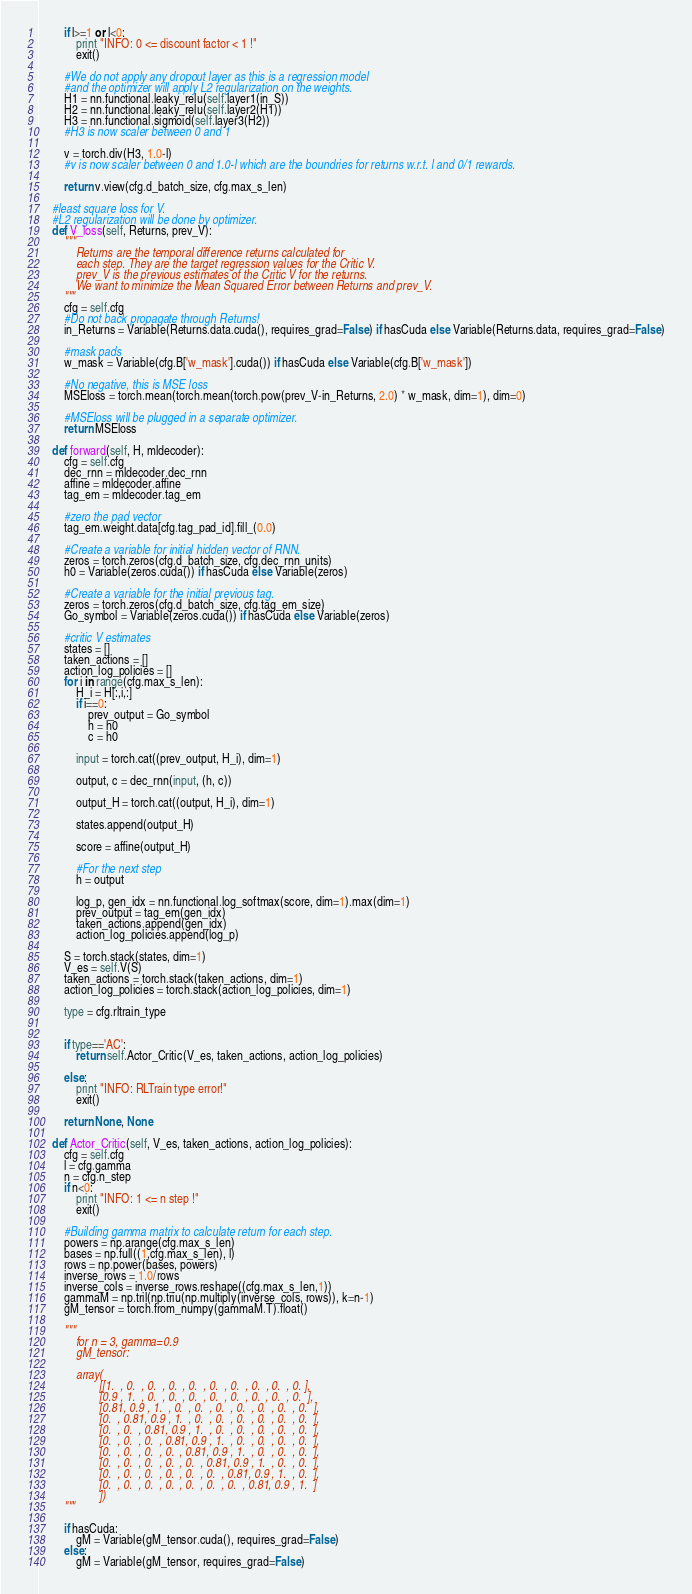<code> <loc_0><loc_0><loc_500><loc_500><_Python_>        if l>=1 or l<0:
            print "INFO: 0 <= discount factor < 1 !"
            exit()

        #We do not apply any dropout layer as this is a regression model
        #and the optimizer will apply L2 regularization on the weights.
        H1 = nn.functional.leaky_relu(self.layer1(in_S))
        H2 = nn.functional.leaky_relu(self.layer2(H1))
        H3 = nn.functional.sigmoid(self.layer3(H2))
        #H3 is now scaler between 0 and 1

        v = torch.div(H3, 1.0-l)
        #v is now scaler between 0 and 1.0-l which are the boundries for returns w.r.t. l and 0/1 rewards.

        return v.view(cfg.d_batch_size, cfg.max_s_len)

    #least square loss for V.
    #L2 regularization will be done by optimizer.
    def V_loss(self, Returns, prev_V):
        """
            Returns are the temporal difference returns calculated for
            each step. They are the target regression values for the Critic V.
            prev_V is the previous estimates of the Critic V for the returns.
            We want to minimize the Mean Squared Error between Returns and prev_V.
        """
        cfg = self.cfg
        #Do not back propagate through Returns!
        in_Returns = Variable(Returns.data.cuda(), requires_grad=False) if hasCuda else Variable(Returns.data, requires_grad=False)

        #mask pads
        w_mask = Variable(cfg.B['w_mask'].cuda()) if hasCuda else Variable(cfg.B['w_mask'])

        #No negative, this is MSE loss
        MSEloss = torch.mean(torch.mean(torch.pow(prev_V-in_Returns, 2.0) * w_mask, dim=1), dim=0)

        #MSEloss will be plugged in a separate optimizer.
        return MSEloss

    def forward(self, H, mldecoder):
        cfg = self.cfg
        dec_rnn = mldecoder.dec_rnn
        affine = mldecoder.affine
        tag_em = mldecoder.tag_em

        #zero the pad vector
        tag_em.weight.data[cfg.tag_pad_id].fill_(0.0)

        #Create a variable for initial hidden vector of RNN.
        zeros = torch.zeros(cfg.d_batch_size, cfg.dec_rnn_units)
        h0 = Variable(zeros.cuda()) if hasCuda else Variable(zeros)

        #Create a variable for the initial previous tag.
        zeros = torch.zeros(cfg.d_batch_size, cfg.tag_em_size)
        Go_symbol = Variable(zeros.cuda()) if hasCuda else Variable(zeros)

        #critic V estimates
        states = []
        taken_actions = []
        action_log_policies = []
        for i in range(cfg.max_s_len):
            H_i = H[:,i,:]
            if i==0:
                prev_output = Go_symbol
                h = h0
                c = h0

            input = torch.cat((prev_output, H_i), dim=1)

            output, c = dec_rnn(input, (h, c))

            output_H = torch.cat((output, H_i), dim=1)

            states.append(output_H)

            score = affine(output_H)

            #For the next step
            h = output

            log_p, gen_idx = nn.functional.log_softmax(score, dim=1).max(dim=1)
            prev_output = tag_em(gen_idx)
            taken_actions.append(gen_idx)
            action_log_policies.append(log_p)

        S = torch.stack(states, dim=1)
        V_es = self.V(S)
        taken_actions = torch.stack(taken_actions, dim=1)
        action_log_policies = torch.stack(action_log_policies, dim=1)

        type = cfg.rltrain_type


        if type=='AC':
            return self.Actor_Critic(V_es, taken_actions, action_log_policies)

        else:
            print "INFO: RLTrain type error!"
            exit()

        return None, None

    def Actor_Critic(self, V_es, taken_actions, action_log_policies):
        cfg = self.cfg
        l = cfg.gamma
        n = cfg.n_step
        if n<0:
            print "INFO: 1 <= n step !"
            exit()

        #Building gamma matrix to calculate return for each step.
        powers = np.arange(cfg.max_s_len)
        bases = np.full((1,cfg.max_s_len), l)
        rows = np.power(bases, powers)
        inverse_rows = 1.0/rows
        inverse_cols = inverse_rows.reshape((cfg.max_s_len,1))
        gammaM = np.tril(np.triu(np.multiply(inverse_cols, rows)), k=n-1)
        gM_tensor = torch.from_numpy(gammaM.T).float()

        """
            for n = 3, gamma=0.9
            gM_tensor:

            array(
                    [[1.  , 0.  , 0.  , 0.  , 0.  , 0.  , 0.  , 0.  , 0.  , 0. ],
                    [0.9 , 1.  , 0.  , 0.  , 0.  , 0.  , 0.  , 0.  , 0.  , 0.  ],
                    [0.81, 0.9 , 1.  , 0.  , 0.  , 0.  , 0.  , 0.  , 0.  , 0.  ],
                    [0.  , 0.81, 0.9 , 1.  , 0.  , 0.  , 0.  , 0.  , 0.  , 0.  ],
                    [0.  , 0.  , 0.81, 0.9 , 1.  , 0.  , 0.  , 0.  , 0.  , 0.  ],
                    [0.  , 0.  , 0.  , 0.81, 0.9 , 1.  , 0.  , 0.  , 0.  , 0.  ],
                    [0.  , 0.  , 0.  , 0.  , 0.81, 0.9 , 1.  , 0.  , 0.  , 0.  ],
                    [0.  , 0.  , 0.  , 0.  , 0.  , 0.81, 0.9 , 1.  , 0.  , 0.  ],
                    [0.  , 0.  , 0.  , 0.  , 0.  , 0.  , 0.81, 0.9 , 1.  , 0.  ],
                    [0.  , 0.  , 0.  , 0.  , 0.  , 0.  , 0.  , 0.81, 0.9 , 1.  ]
                    ])
        """

        if hasCuda:
            gM = Variable(gM_tensor.cuda(), requires_grad=False)
        else:
            gM = Variable(gM_tensor, requires_grad=False)
</code> 